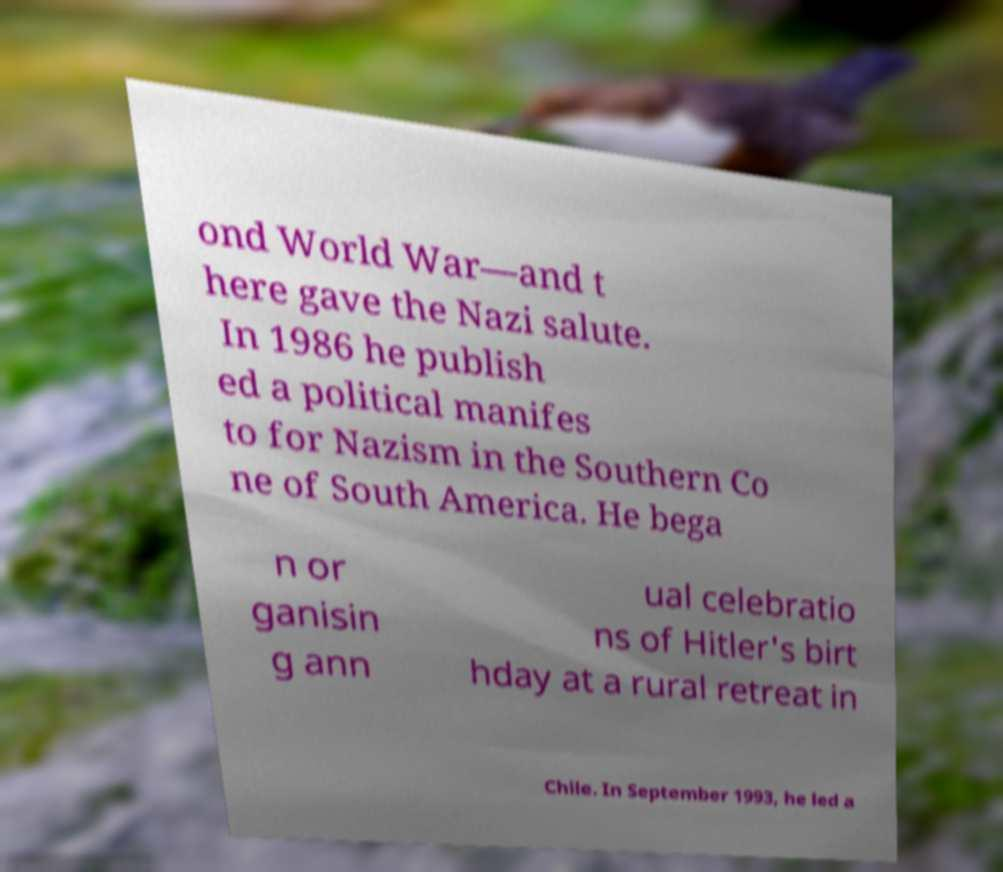There's text embedded in this image that I need extracted. Can you transcribe it verbatim? ond World War—and t here gave the Nazi salute. In 1986 he publish ed a political manifes to for Nazism in the Southern Co ne of South America. He bega n or ganisin g ann ual celebratio ns of Hitler's birt hday at a rural retreat in Chile. In September 1993, he led a 